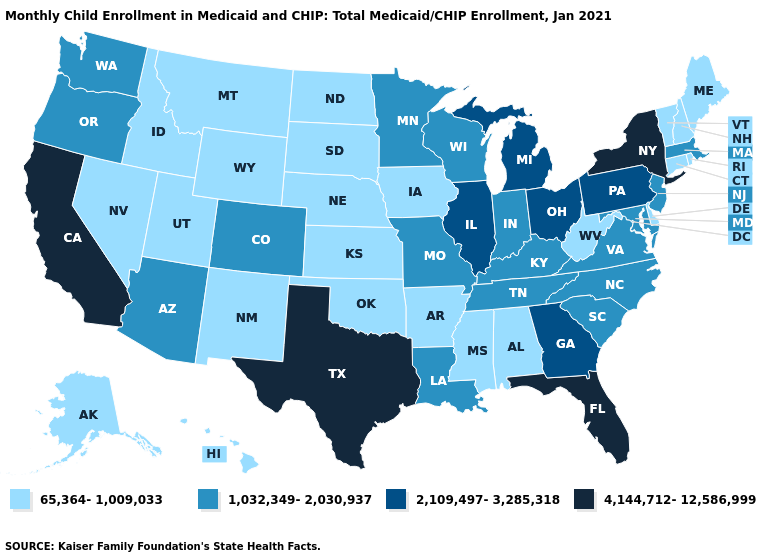Does California have the highest value in the West?
Give a very brief answer. Yes. Does Kentucky have a lower value than New Jersey?
Be succinct. No. Which states have the highest value in the USA?
Quick response, please. California, Florida, New York, Texas. Does the first symbol in the legend represent the smallest category?
Quick response, please. Yes. Does Texas have a lower value than Montana?
Answer briefly. No. Does the map have missing data?
Short answer required. No. What is the value of Ohio?
Write a very short answer. 2,109,497-3,285,318. Does Idaho have the lowest value in the West?
Concise answer only. Yes. Is the legend a continuous bar?
Give a very brief answer. No. What is the lowest value in the USA?
Quick response, please. 65,364-1,009,033. What is the value of Oklahoma?
Concise answer only. 65,364-1,009,033. What is the value of Rhode Island?
Quick response, please. 65,364-1,009,033. Name the states that have a value in the range 65,364-1,009,033?
Be succinct. Alabama, Alaska, Arkansas, Connecticut, Delaware, Hawaii, Idaho, Iowa, Kansas, Maine, Mississippi, Montana, Nebraska, Nevada, New Hampshire, New Mexico, North Dakota, Oklahoma, Rhode Island, South Dakota, Utah, Vermont, West Virginia, Wyoming. Does the map have missing data?
Write a very short answer. No. What is the value of South Carolina?
Quick response, please. 1,032,349-2,030,937. 